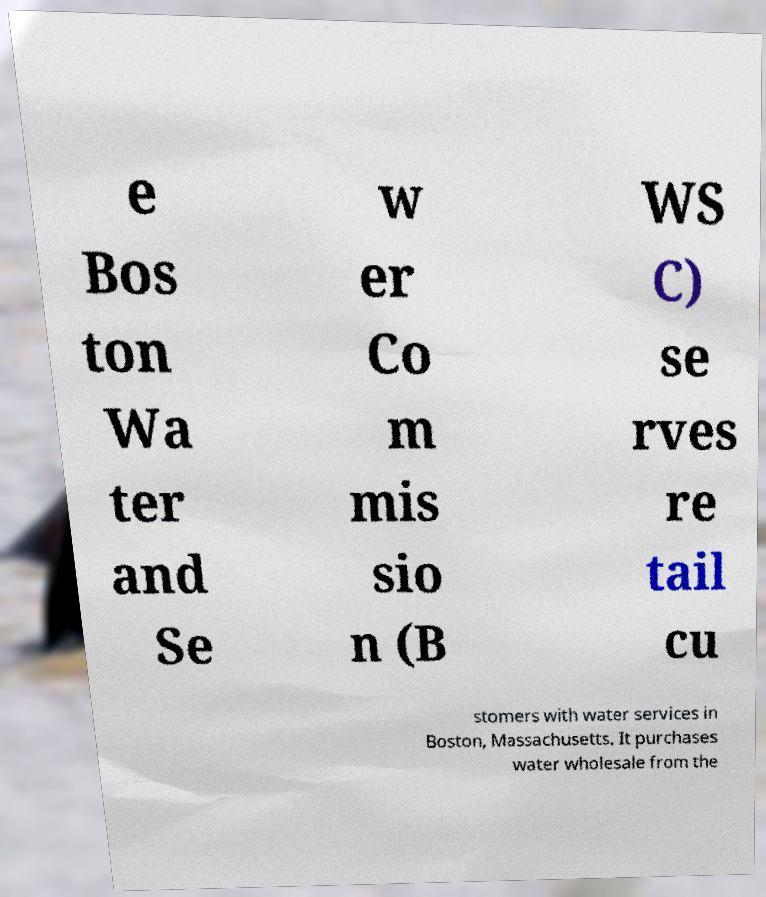Can you read and provide the text displayed in the image?This photo seems to have some interesting text. Can you extract and type it out for me? e Bos ton Wa ter and Se w er Co m mis sio n (B WS C) se rves re tail cu stomers with water services in Boston, Massachusetts. It purchases water wholesale from the 